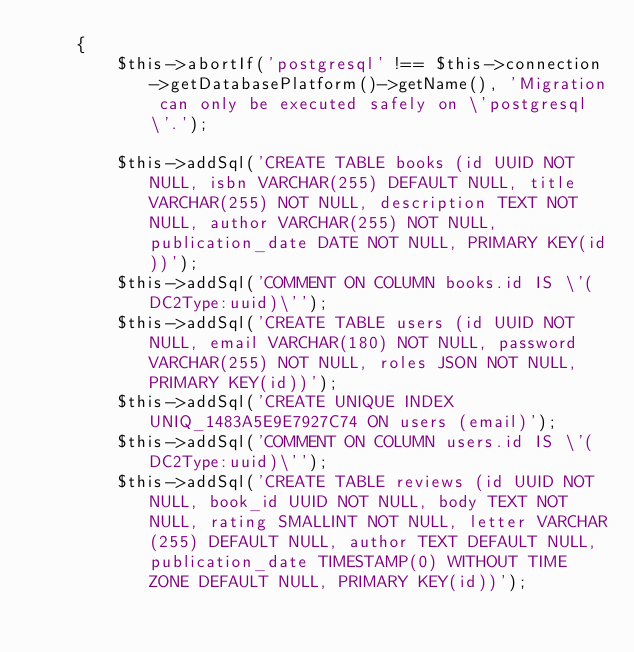Convert code to text. <code><loc_0><loc_0><loc_500><loc_500><_PHP_>    {
        $this->abortIf('postgresql' !== $this->connection->getDatabasePlatform()->getName(), 'Migration can only be executed safely on \'postgresql\'.');

        $this->addSql('CREATE TABLE books (id UUID NOT NULL, isbn VARCHAR(255) DEFAULT NULL, title VARCHAR(255) NOT NULL, description TEXT NOT NULL, author VARCHAR(255) NOT NULL, publication_date DATE NOT NULL, PRIMARY KEY(id))');
        $this->addSql('COMMENT ON COLUMN books.id IS \'(DC2Type:uuid)\'');
        $this->addSql('CREATE TABLE users (id UUID NOT NULL, email VARCHAR(180) NOT NULL, password VARCHAR(255) NOT NULL, roles JSON NOT NULL, PRIMARY KEY(id))');
        $this->addSql('CREATE UNIQUE INDEX UNIQ_1483A5E9E7927C74 ON users (email)');
        $this->addSql('COMMENT ON COLUMN users.id IS \'(DC2Type:uuid)\'');
        $this->addSql('CREATE TABLE reviews (id UUID NOT NULL, book_id UUID NOT NULL, body TEXT NOT NULL, rating SMALLINT NOT NULL, letter VARCHAR(255) DEFAULT NULL, author TEXT DEFAULT NULL, publication_date TIMESTAMP(0) WITHOUT TIME ZONE DEFAULT NULL, PRIMARY KEY(id))');</code> 